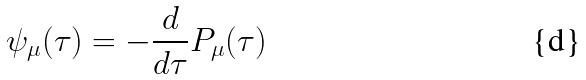<formula> <loc_0><loc_0><loc_500><loc_500>\psi _ { \mu } ( \tau ) = - \frac { d } { d \tau } P _ { \mu } ( \tau )</formula> 